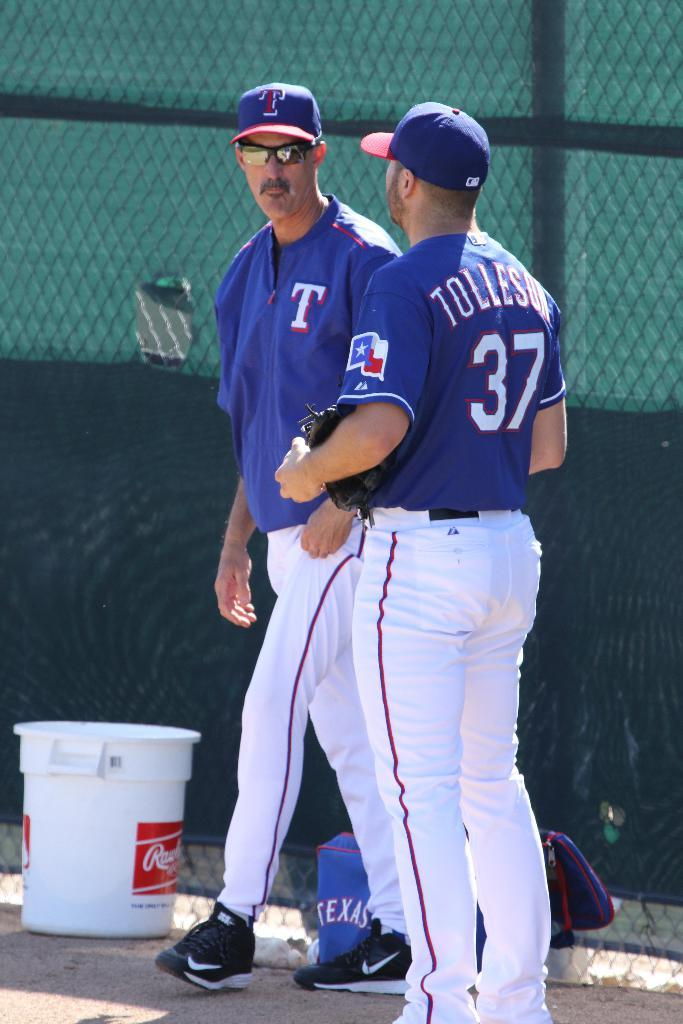<image>
Provide a brief description of the given image. Number thirty seven wears a blue jersey with the Texas flag on the arm. 